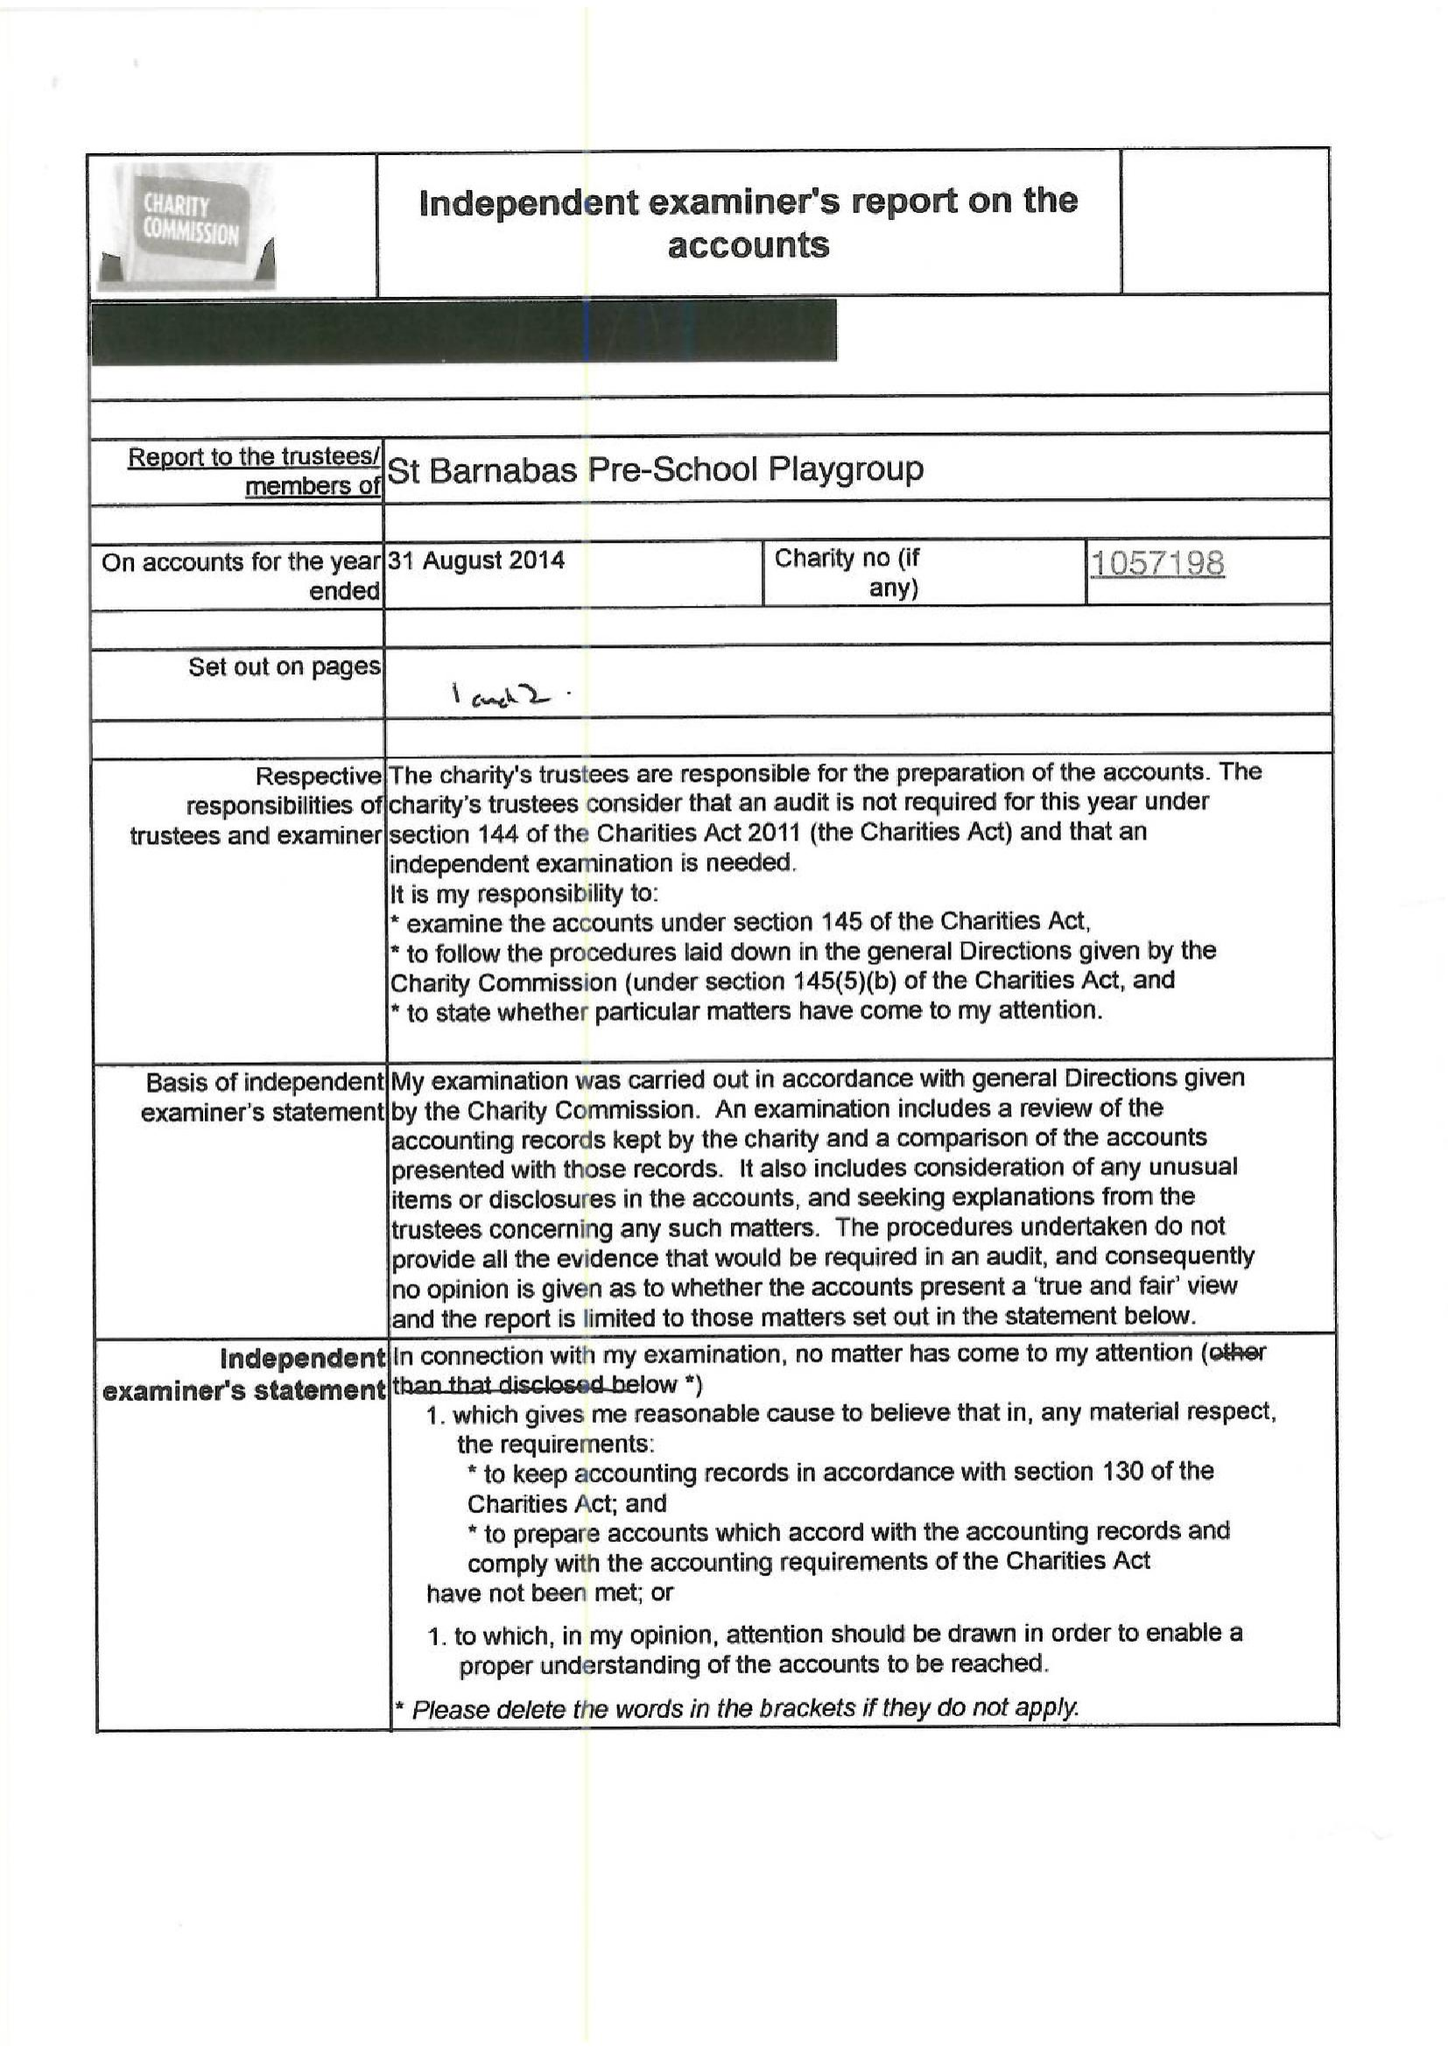What is the value for the charity_number?
Answer the question using a single word or phrase. 1057198 